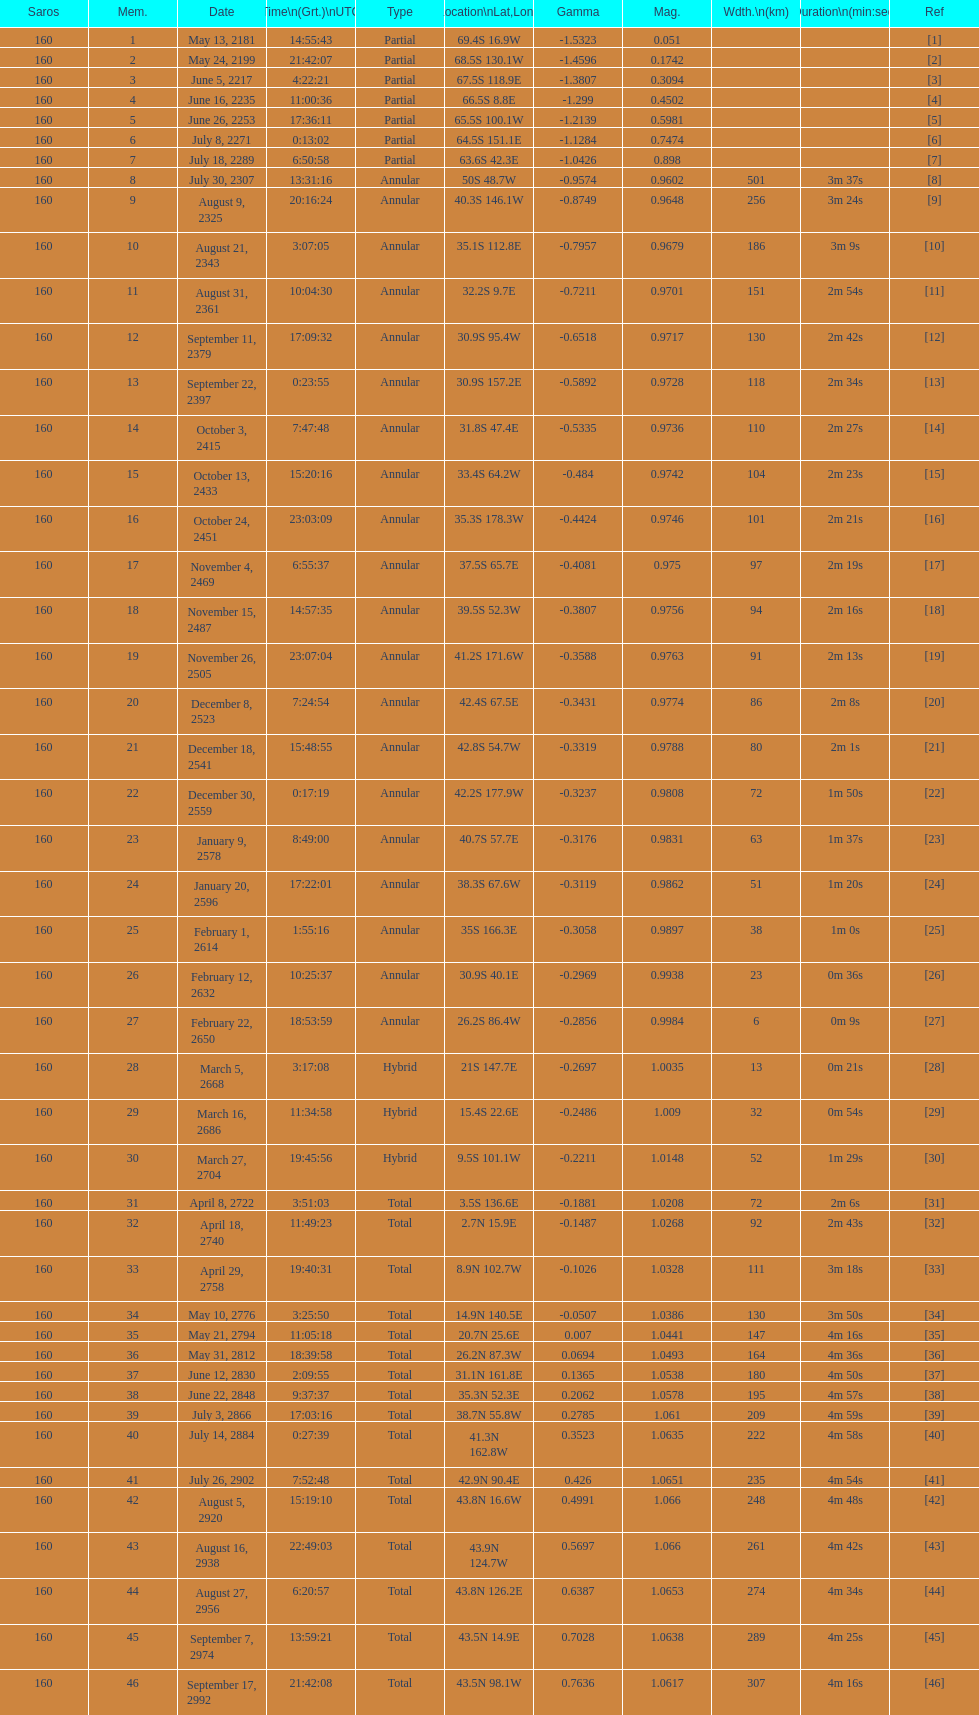What is the difference in magnitude between the may 13, 2181 solar saros and the may 24, 2199 solar saros? 0.1232. 